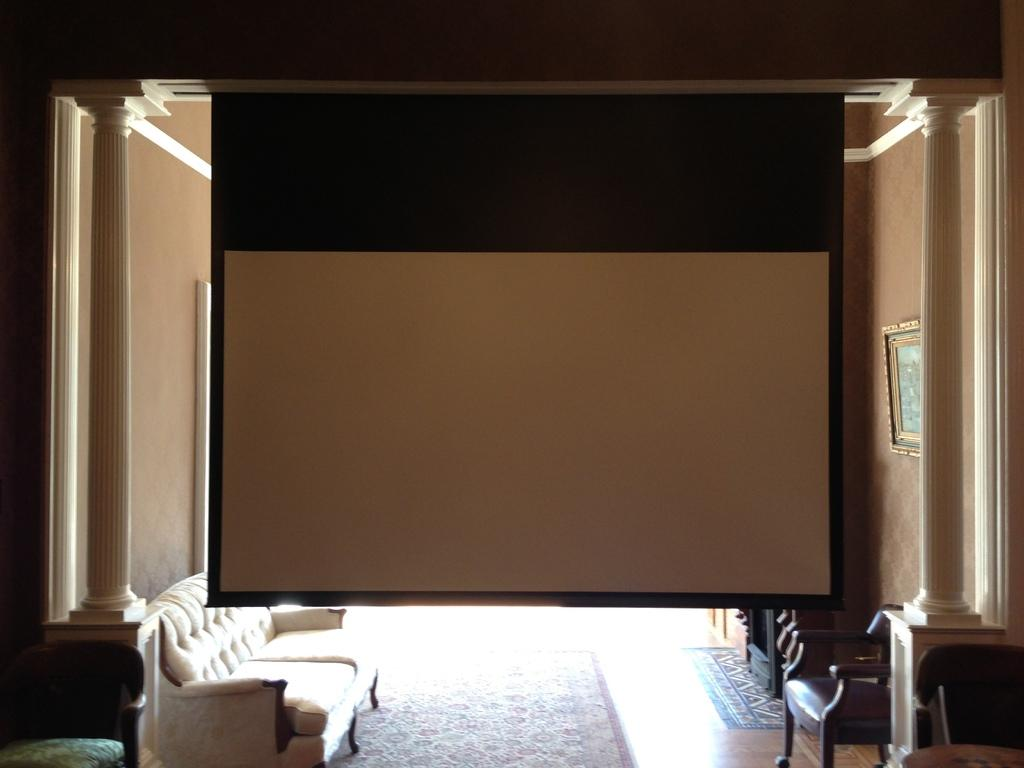What type of furniture is present in the image? There is a sofa and chairs in the image. What can be seen on the wall in the image? There is a frame on a wall in the image. What might be used for displaying visual content in the image? There is a projector screen in the image. How does the frame start sneezing in the image? The frame does not sneeze in the image, as it is an inanimate object and cannot perform such actions. 